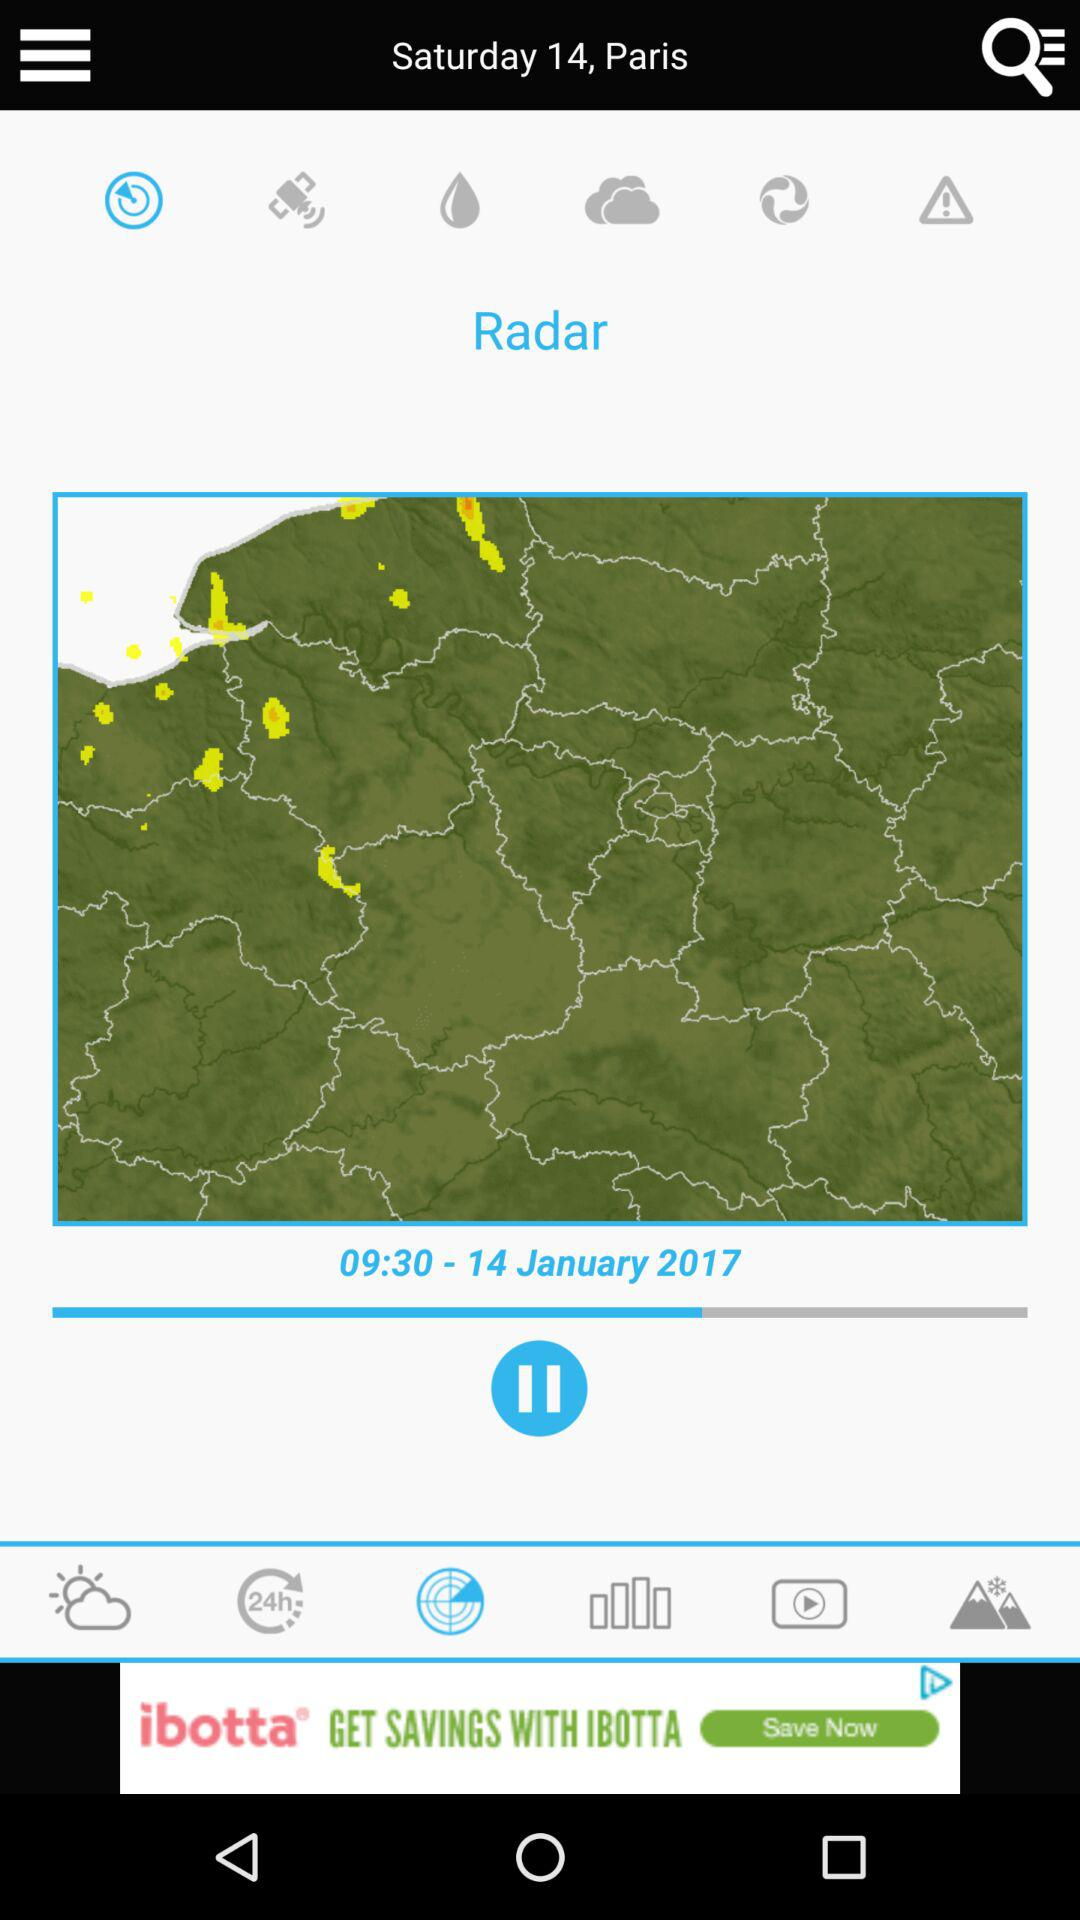What is the date? The date is January 14, 2017. 